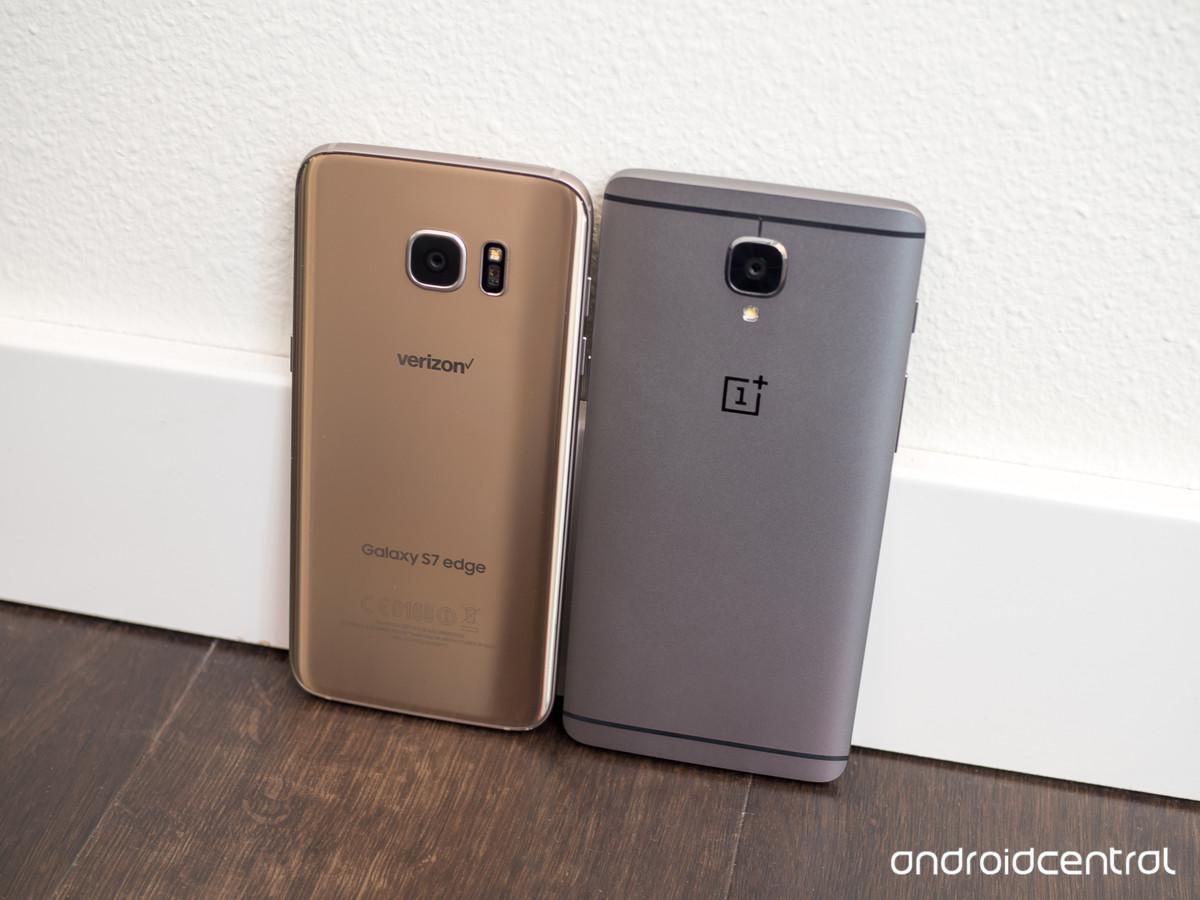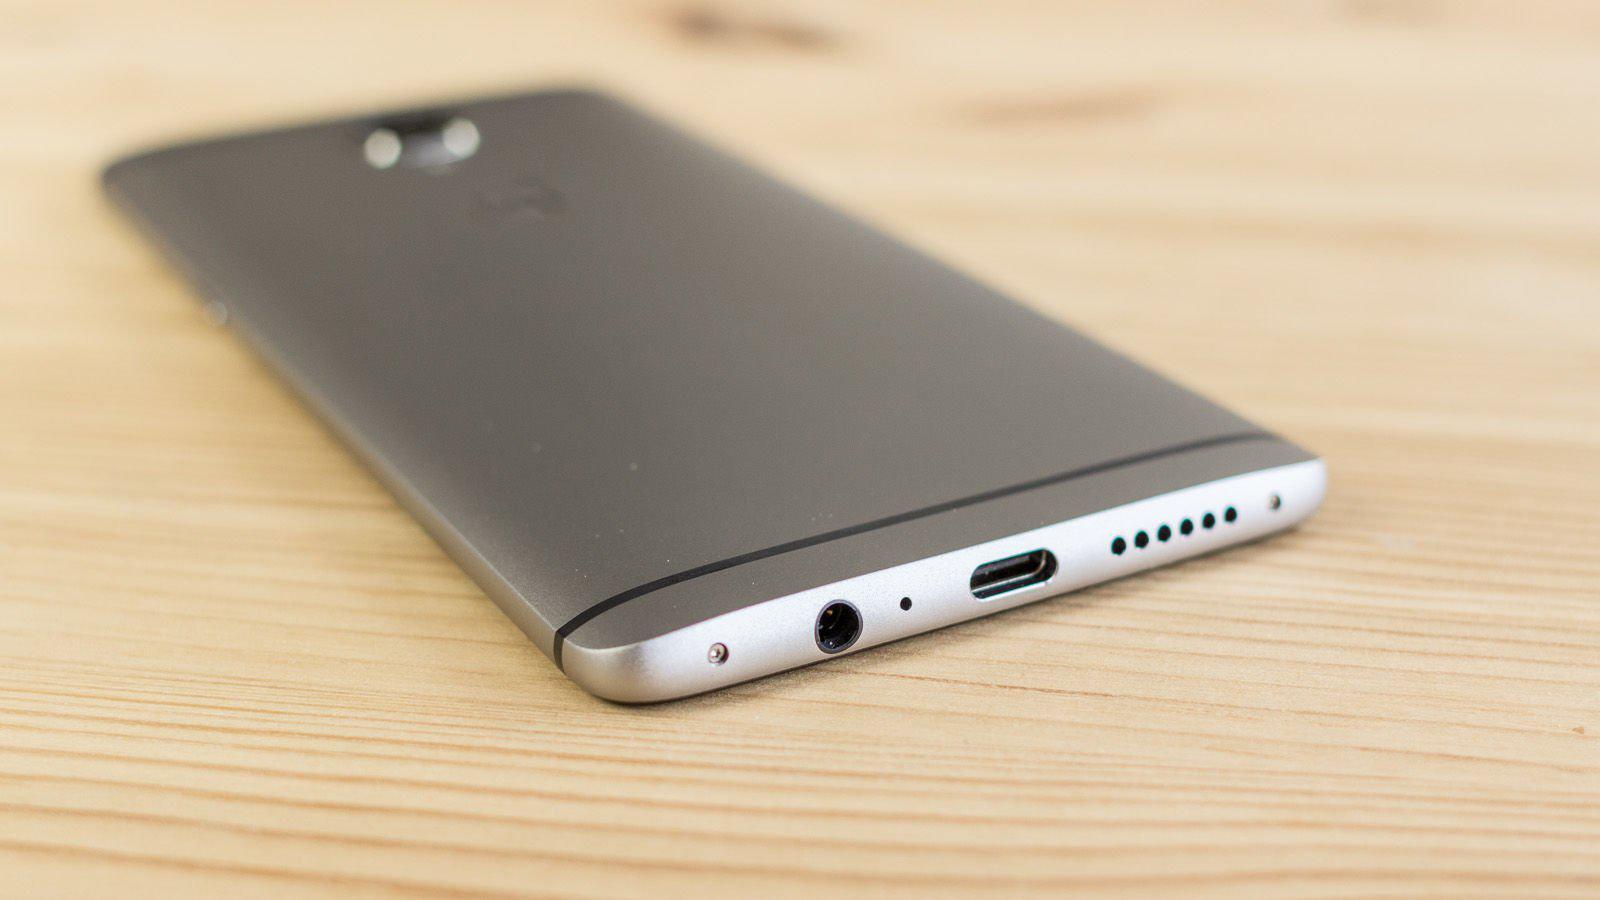The first image is the image on the left, the second image is the image on the right. Given the left and right images, does the statement "The right image shows a hand holding a rectangular screen-front device angled to the left." hold true? Answer yes or no. No. The first image is the image on the left, the second image is the image on the right. For the images shown, is this caption "A person is holding the phone in the image on the right." true? Answer yes or no. No. 